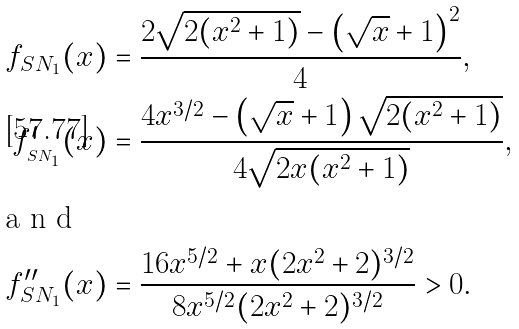Convert formula to latex. <formula><loc_0><loc_0><loc_500><loc_500>f _ { S N _ { 1 } } ( x ) & = \frac { 2 \sqrt { 2 ( x ^ { 2 } + 1 ) } - \left ( { \sqrt { x } + 1 } \right ) ^ { 2 } } { 4 } , \\ { f } ^ { \prime } _ { _ { S N _ { 1 } } } ( x ) & = \frac { 4 x ^ { 3 / 2 } - \left ( { \sqrt { x } + 1 } \right ) \sqrt { 2 ( x ^ { 2 } + 1 ) } } { 4 \sqrt { 2 x ( x ^ { 2 } + 1 ) } } , \intertext { a n d } { f } ^ { \prime \prime } _ { S N _ { 1 } } ( x ) & = \frac { 1 6 x ^ { 5 / 2 } + x ( 2 x ^ { 2 } + 2 ) ^ { 3 / 2 } } { 8 x ^ { 5 / 2 } ( 2 x ^ { 2 } + 2 ) ^ { 3 / 2 } } > 0 .</formula> 